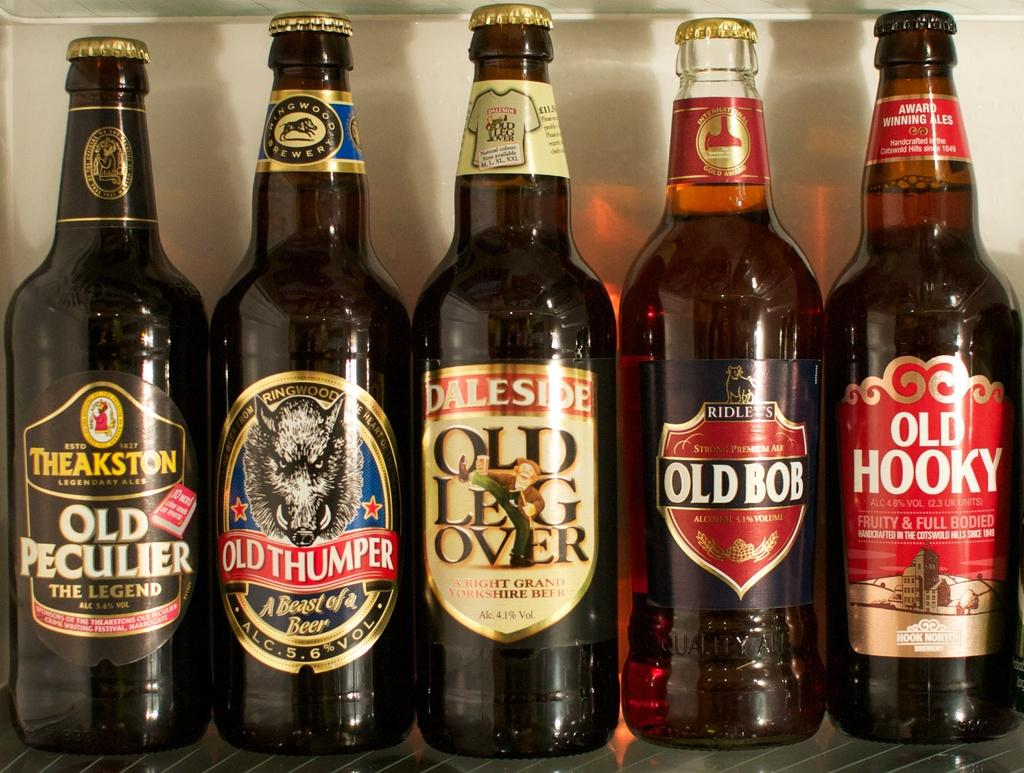<image>
Summarize the visual content of the image. Five bottles of beer including Old Bob and Old Hooky beers. 